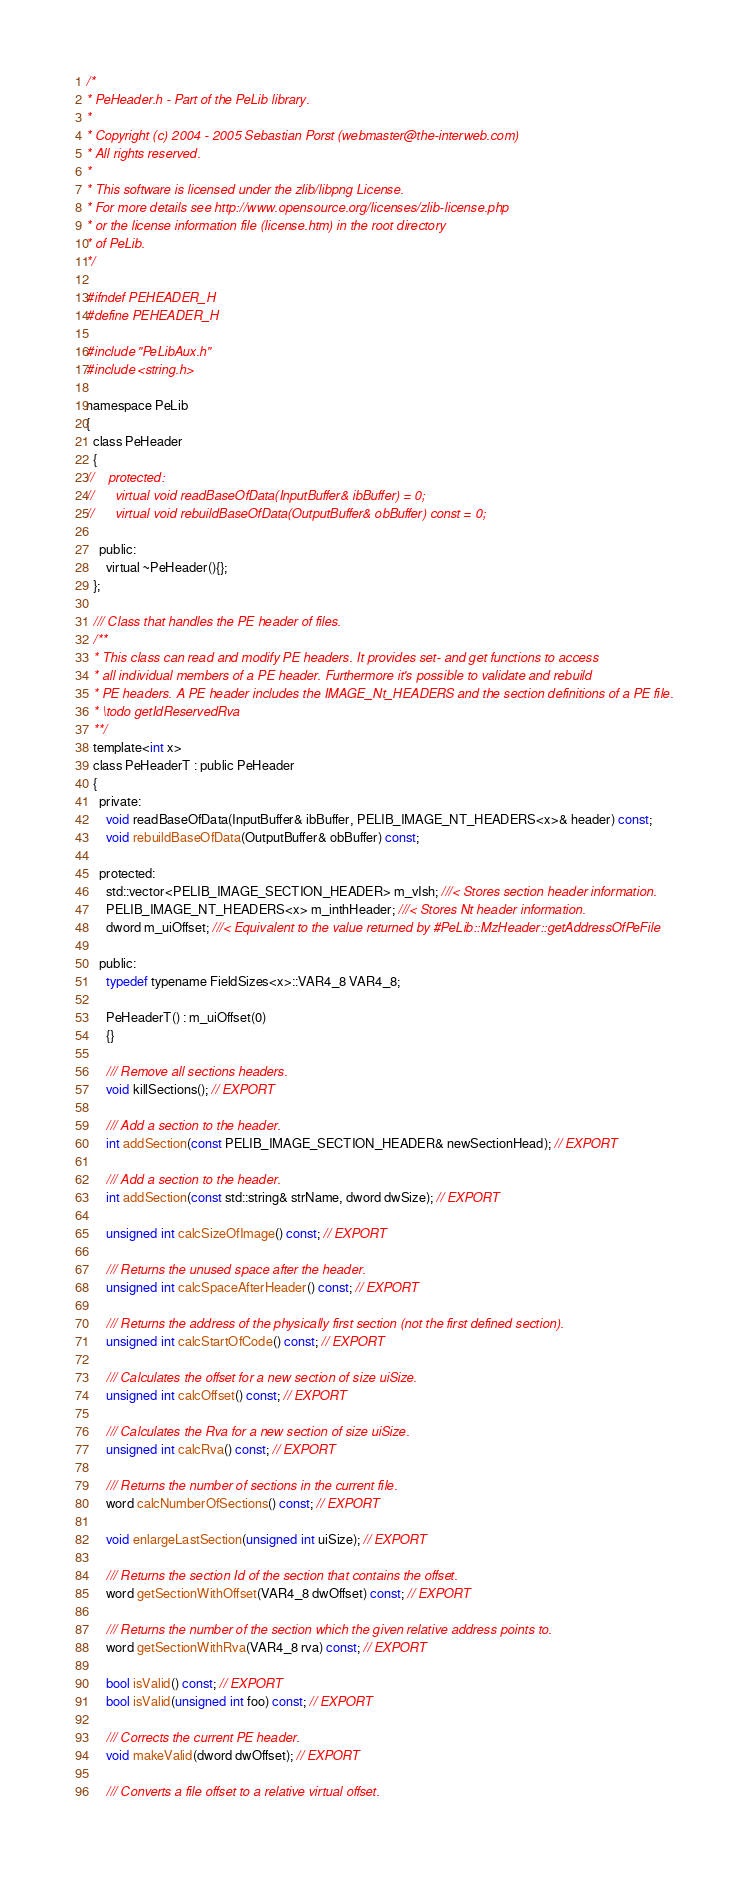<code> <loc_0><loc_0><loc_500><loc_500><_C_>/*
* PeHeader.h - Part of the PeLib library.
*
* Copyright (c) 2004 - 2005 Sebastian Porst (webmaster@the-interweb.com)
* All rights reserved.
*
* This software is licensed under the zlib/libpng License.
* For more details see http://www.opensource.org/licenses/zlib-license.php
* or the license information file (license.htm) in the root directory 
* of PeLib.
*/

#ifndef PEHEADER_H
#define PEHEADER_H

#include "PeLibAux.h"
#include <string.h>

namespace PeLib
{
  class PeHeader
  {
//    protected:
//      virtual void readBaseOfData(InputBuffer& ibBuffer) = 0;
//      virtual void rebuildBaseOfData(OutputBuffer& obBuffer) const = 0;
      
    public:
      virtual ~PeHeader(){};
  };
  
  /// Class that handles the PE header of files.
  /**
  * This class can read and modify PE headers. It provides set- and get functions to access
  * all individual members of a PE header. Furthermore it's possible to validate and rebuild
  * PE headers. A PE header includes the IMAGE_Nt_HEADERS and the section definitions of a PE file.
  * \todo getIdReservedRva
  **/
  template<int x>
  class PeHeaderT : public PeHeader
  {
    private:
      void readBaseOfData(InputBuffer& ibBuffer, PELIB_IMAGE_NT_HEADERS<x>& header) const;
      void rebuildBaseOfData(OutputBuffer& obBuffer) const;
    
    protected:
      std::vector<PELIB_IMAGE_SECTION_HEADER> m_vIsh; ///< Stores section header information.
      PELIB_IMAGE_NT_HEADERS<x> m_inthHeader; ///< Stores Nt header information.
      dword m_uiOffset; ///< Equivalent to the value returned by #PeLib::MzHeader::getAddressOfPeFile

    public:
      typedef typename FieldSizes<x>::VAR4_8 VAR4_8;
    
      PeHeaderT() : m_uiOffset(0)
      {}

      /// Remove all sections headers.
      void killSections(); // EXPORT

      /// Add a section to the header.
      int addSection(const PELIB_IMAGE_SECTION_HEADER& newSectionHead); // EXPORT

      /// Add a section to the header.
      int addSection(const std::string& strName, dword dwSize); // EXPORT
      
      unsigned int calcSizeOfImage() const; // EXPORT
      
      /// Returns the unused space after the header.
      unsigned int calcSpaceAfterHeader() const; // EXPORT
      
      /// Returns the address of the physically first section (not the first defined section).
      unsigned int calcStartOfCode() const; // EXPORT

      /// Calculates the offset for a new section of size uiSize.
      unsigned int calcOffset() const; // EXPORT

      /// Calculates the Rva for a new section of size uiSize.
      unsigned int calcRva() const; // EXPORT
      
      /// Returns the number of sections in the current file.
      word calcNumberOfSections() const; // EXPORT

      void enlargeLastSection(unsigned int uiSize); // EXPORT
      
      /// Returns the section Id of the section that contains the offset.
      word getSectionWithOffset(VAR4_8 dwOffset) const; // EXPORT

      /// Returns the number of the section which the given relative address points to.
      word getSectionWithRva(VAR4_8 rva) const; // EXPORT

      bool isValid() const; // EXPORT
      bool isValid(unsigned int foo) const; // EXPORT

      /// Corrects the current PE header.
      void makeValid(dword dwOffset); // EXPORT

      /// Converts a file offset to a relative virtual offset.</code> 